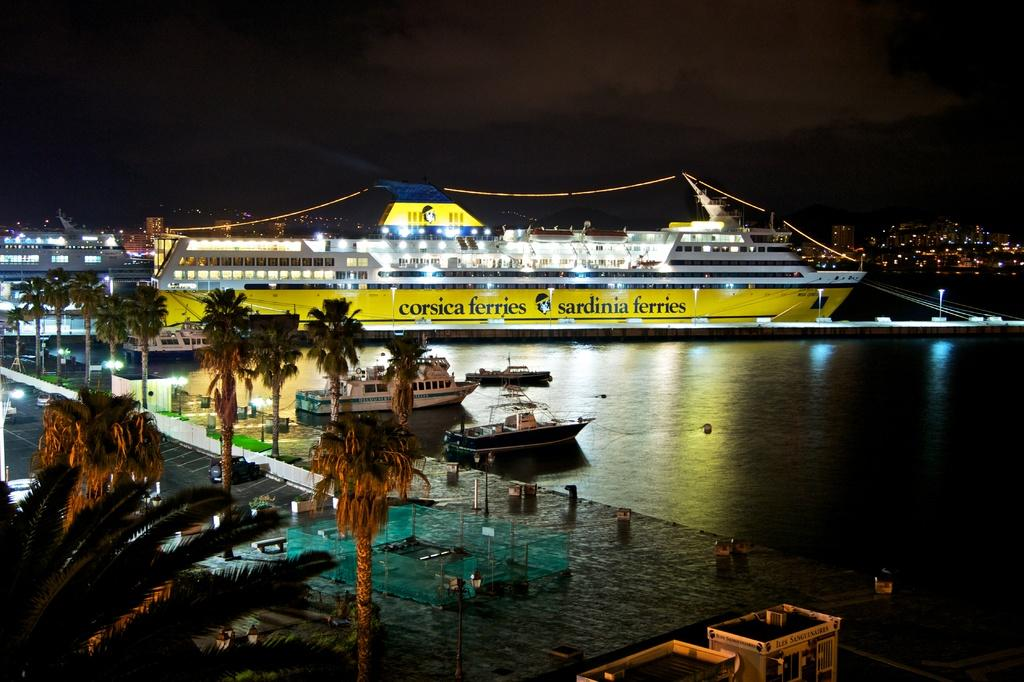What is the main subject in the foreground of the image? There is a shipyard in the foreground of the image. What type of natural elements can be seen in the image? There are trees in the image. What kind of feature is present for walking or traveling? There is a path in the image. What types of vehicles are visible in the image? Vehicles are present in the image. What is used to enclose or separate areas in the image? There is fencing in the image. What natural element is visible in the image? Water is visible in the image. What types of watercraft are present in the image? Ships and boats are present in the image. What type of structure is visible in the image? There is a building in the image. What is used for illumination in the image? Lights are visible in the image. What type of vertical structures are present in the image? Poles are present in the image. How would you describe the lighting conditions at the top of the image? The top side of the image is dark. What type of growth can be seen on the throne in the image? There is no throne present in the image. How many bites has the person taken out of the boat in the image? There is no person biting the boat in the image; boats are not edible. 